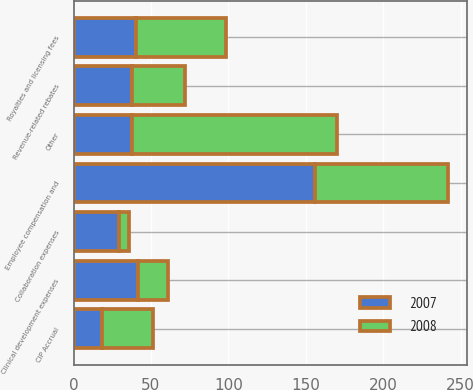<chart> <loc_0><loc_0><loc_500><loc_500><stacked_bar_chart><ecel><fcel>Employee compensation and<fcel>Royalties and licensing fees<fcel>Collaboration expenses<fcel>Clinical development expenses<fcel>Revenue-related rebates<fcel>CIP Accrual<fcel>Other<nl><fcel>2007<fcel>156<fcel>40.6<fcel>29.6<fcel>41.5<fcel>37.7<fcel>18.6<fcel>37.7<nl><fcel>2008<fcel>86<fcel>57.6<fcel>5.9<fcel>19.4<fcel>34.1<fcel>32.6<fcel>132.3<nl></chart> 